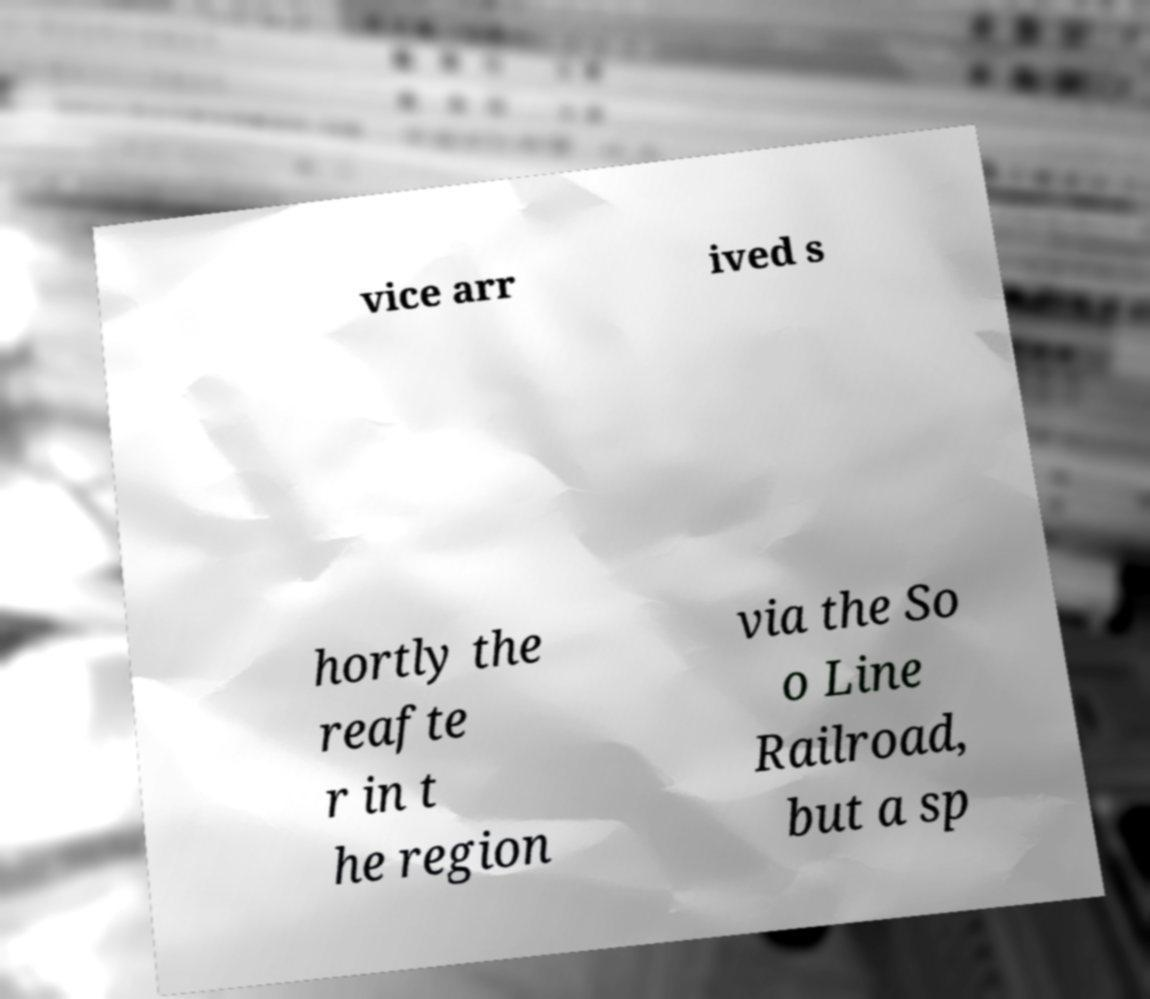What messages or text are displayed in this image? I need them in a readable, typed format. vice arr ived s hortly the reafte r in t he region via the So o Line Railroad, but a sp 